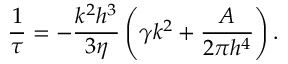<formula> <loc_0><loc_0><loc_500><loc_500>\frac { 1 } { \tau } = - \frac { k ^ { 2 } h ^ { 3 } } { 3 \eta } \left ( \gamma k ^ { 2 } + \frac { A } { 2 \pi h ^ { 4 } } \right ) .</formula> 